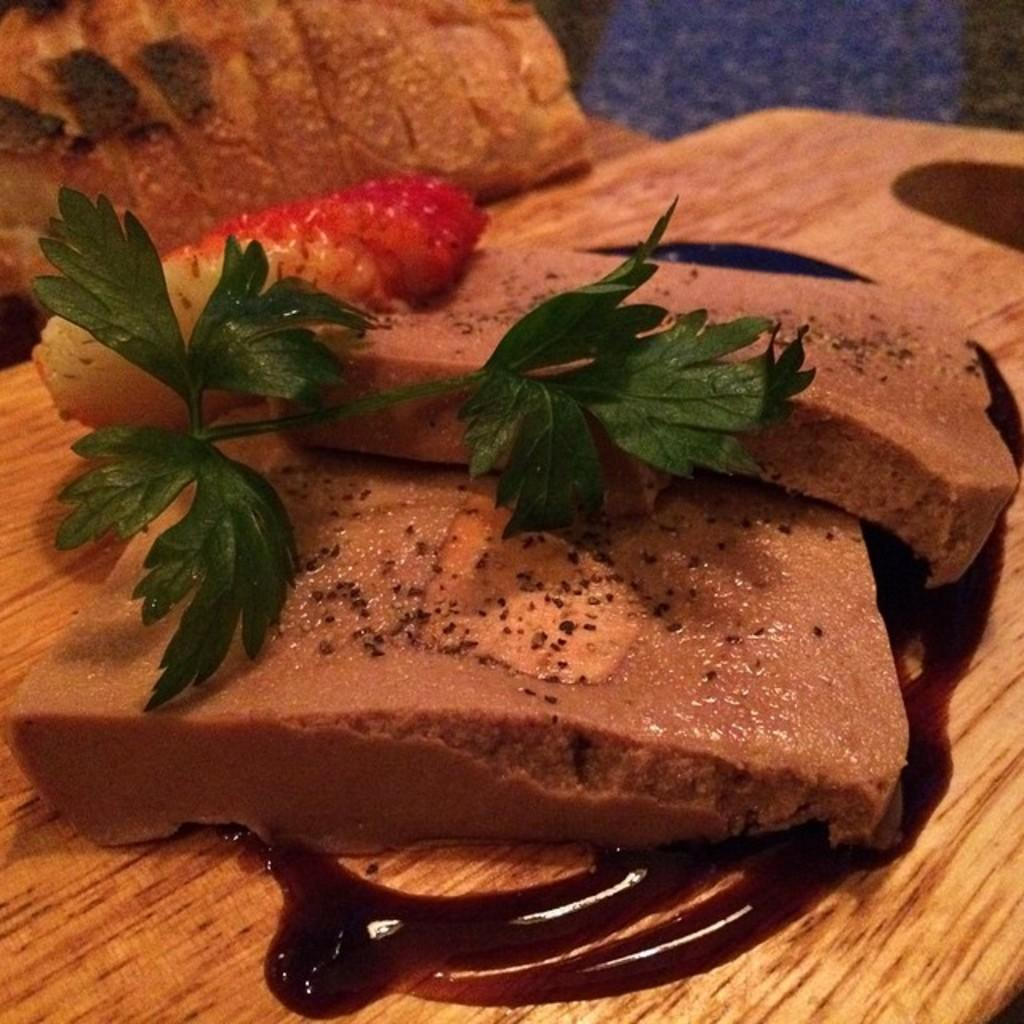What types of items can be seen in the image? There are food items in the image. On what surface are the food items placed? The food items are on a wooden surface. Can you see the kitty's toes in the image? There is no kitty or any toes visible in the image; it only features food items on a wooden surface. 